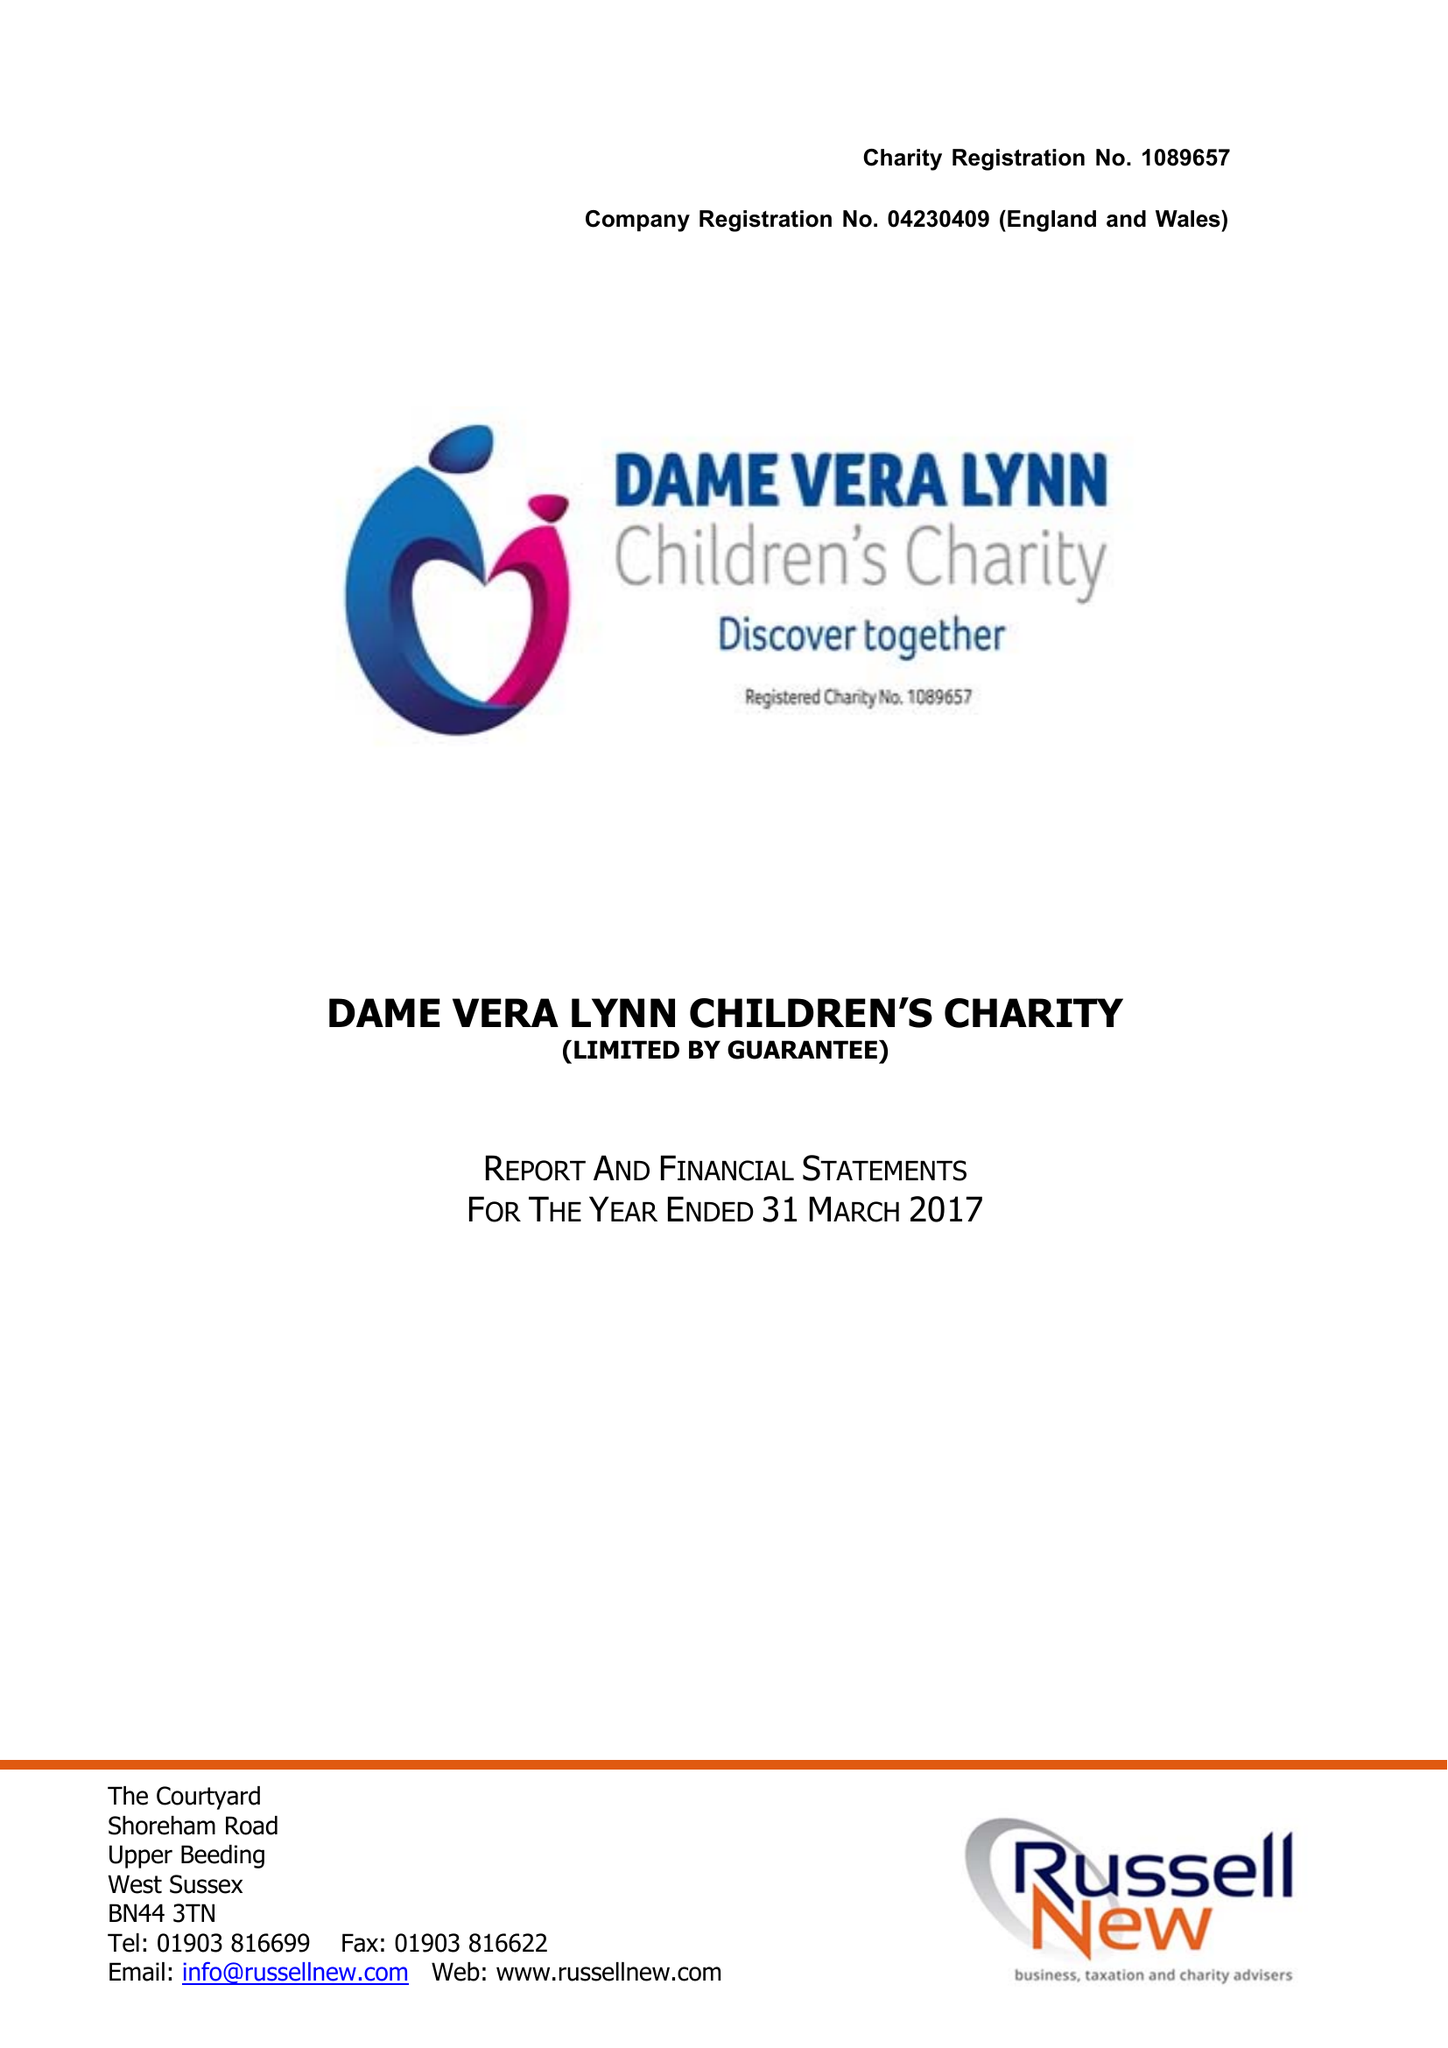What is the value for the charity_number?
Answer the question using a single word or phrase. 1089657 